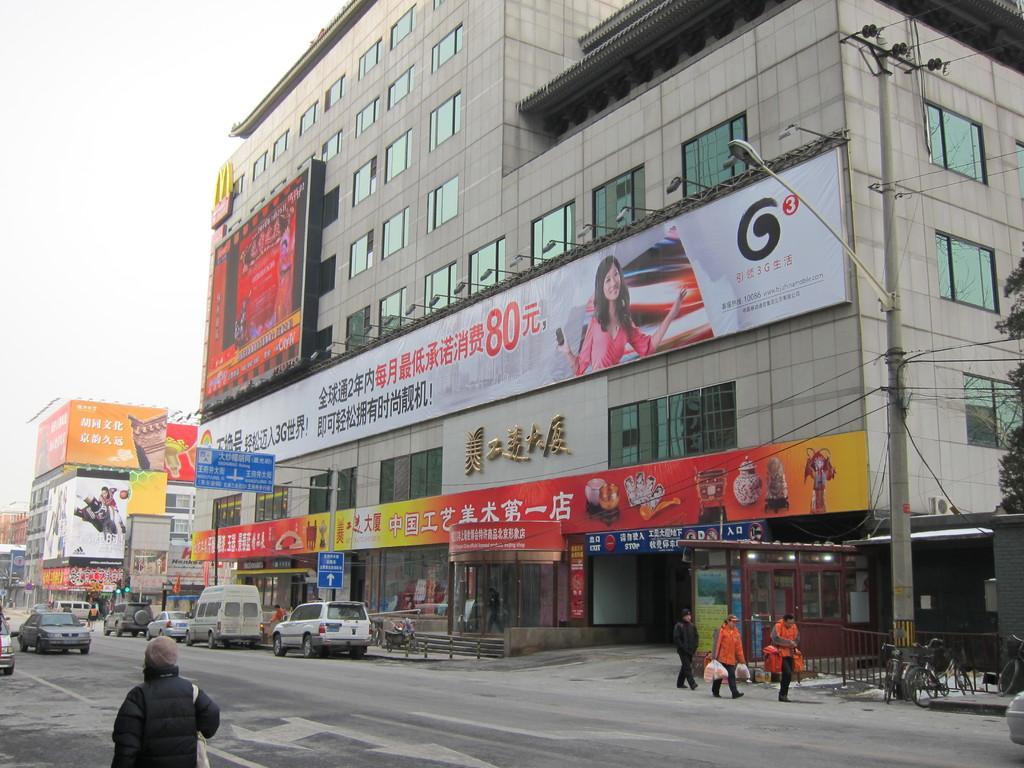How would you summarize this image in a sentence or two? There are few buildings,vehicles and persons in the right corner and there is another person and few vehicles in the left corner. 